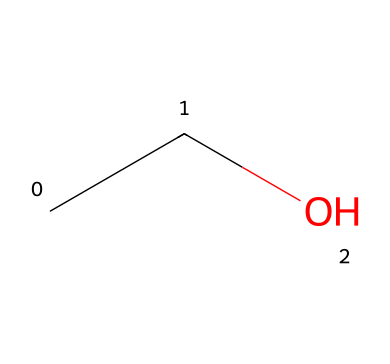What is the molecular formula of this compound? The compound is represented by the SMILES notation "CCO," which indicates two carbon atoms (C), six hydrogen atoms (H), and one oxygen atom (O). Thus, the molecular formula is C2H6O.
Answer: C2H6O How many carbon atoms are in this structure? The SMILES representation "CCO" shows two 'C' characters, indicating there are two carbon atoms in the structure.
Answer: 2 What type of functional group is present in this compound? The "CCO" structure indicates the presence of a hydroxyl group (-OH) attached to a carbon chain, characteristic of alcohols. This means the functional group is an alcohol group.
Answer: alcohol What is the total number of atoms in this compound? The analysis of the molecular formula (C2H6O) shows that there are 2 carbon atoms, 6 hydrogen atoms, and 1 oxygen atom. Adding these gives 9 total atoms.
Answer: 9 What type of isomerism can this compound exhibit? Being a simple alcohol with a straightforward chain, this compound can exhibit structural isomerism, specifically when considering variations in carbon chain arrangement (e.g., branching). However, as a two-carbon structure, specific isomerism forms are limited.
Answer: structural isomerism Does this compound participate in hydrogen bonding? The presence of a hydroxyl group (-OH) indicates that the compound can form hydrogen bonds, as alcohols are known to engage in hydrogen bonding due to the electronegative oxygen atom and available hydrogen.
Answer: yes In what type of transportation applications is this compound commonly utilized? Ethanol, the molecule represented by "CCO," is commonly used as a biofuel additive in gasoline for vehicles, contributing to more sustainable transportation solutions.
Answer: biofuel 